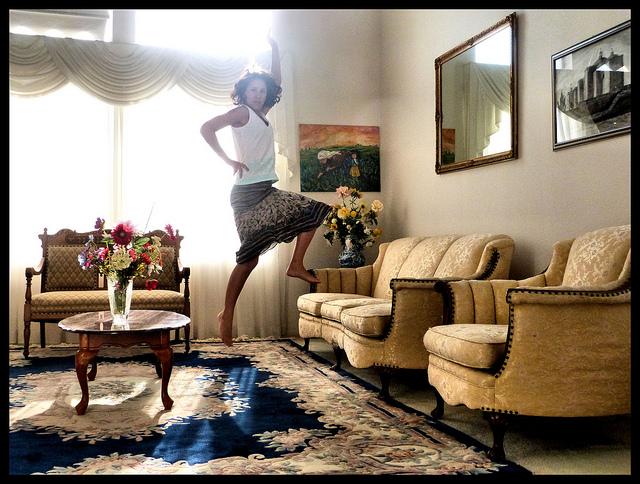What Color is the carpet?
Concise answer only. Blue and tan. What is the woman doing?
Concise answer only. Jumping. What room of the house is this?
Keep it brief. Living room. 